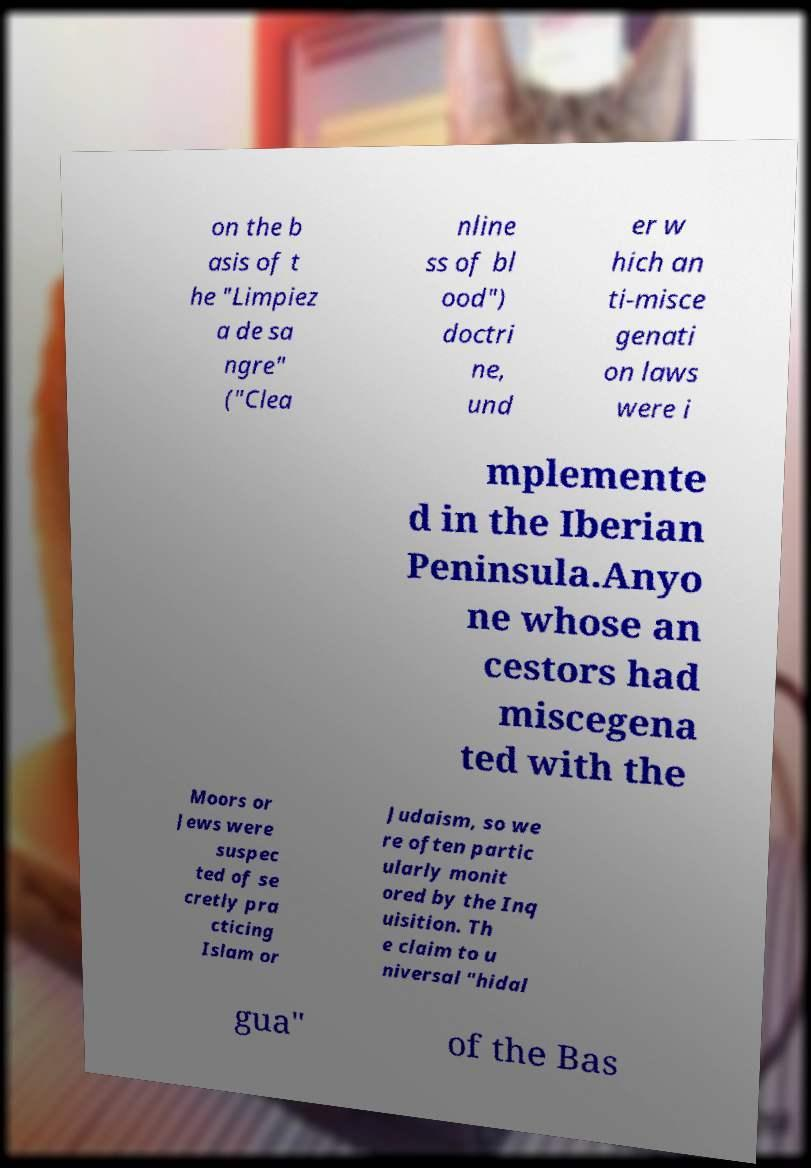What messages or text are displayed in this image? I need them in a readable, typed format. on the b asis of t he "Limpiez a de sa ngre" ("Clea nline ss of bl ood") doctri ne, und er w hich an ti-misce genati on laws were i mplemente d in the Iberian Peninsula.Anyo ne whose an cestors had miscegena ted with the Moors or Jews were suspec ted of se cretly pra cticing Islam or Judaism, so we re often partic ularly monit ored by the Inq uisition. Th e claim to u niversal "hidal gua" of the Bas 